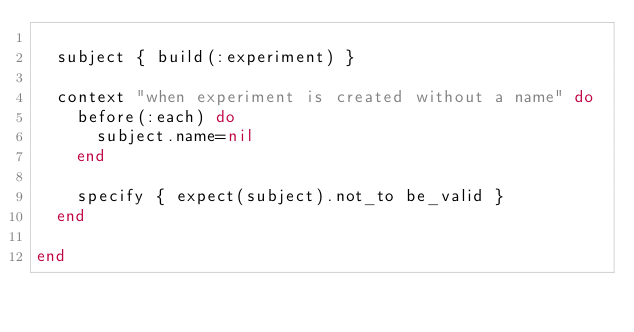Convert code to text. <code><loc_0><loc_0><loc_500><loc_500><_Ruby_>
  subject { build(:experiment) }

  context "when experiment is created without a name" do
    before(:each) do
      subject.name=nil
    end

    specify { expect(subject).not_to be_valid }
  end

end</code> 